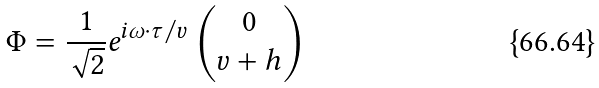Convert formula to latex. <formula><loc_0><loc_0><loc_500><loc_500>\Phi = \frac { 1 } { \sqrt { 2 } } e ^ { i \omega \cdot \tau / v } \left ( \begin{matrix} 0 \\ v + h \end{matrix} \right )</formula> 